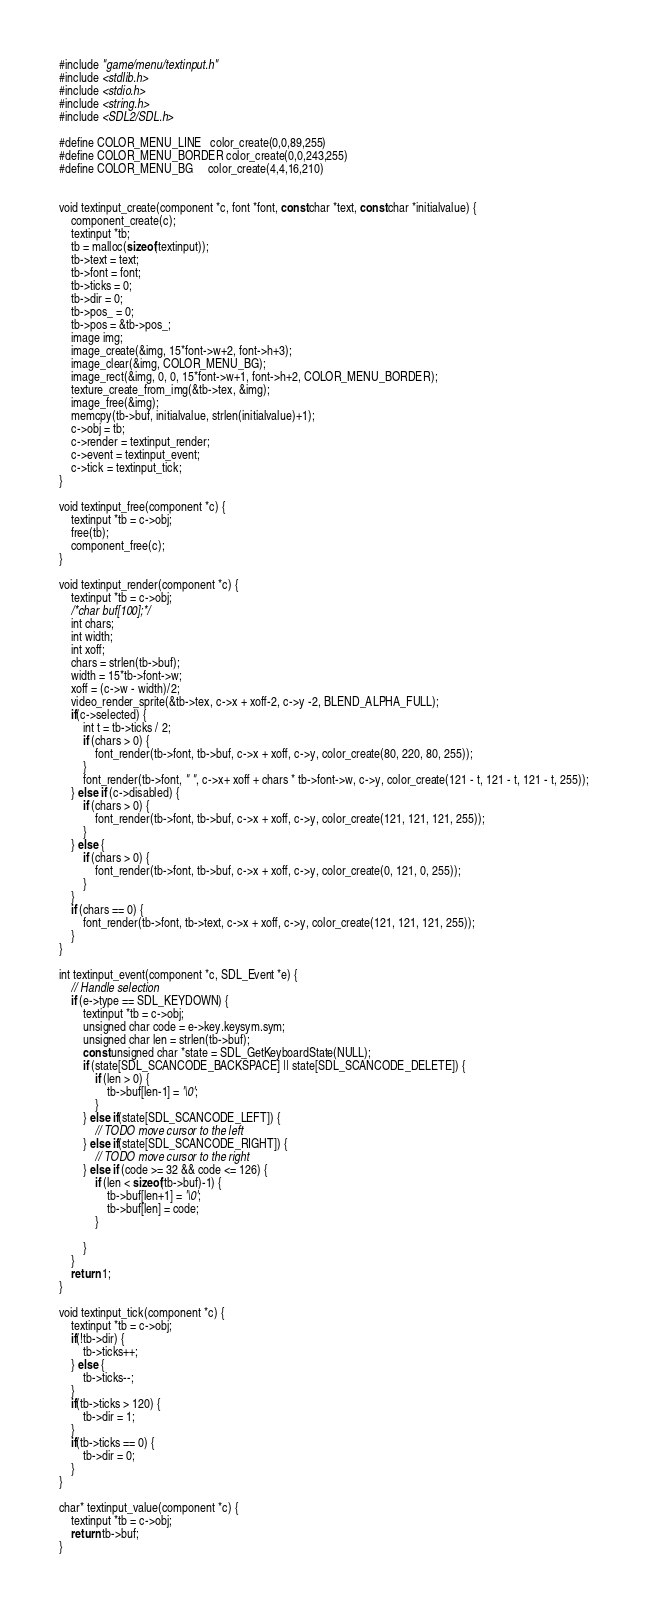Convert code to text. <code><loc_0><loc_0><loc_500><loc_500><_C_>#include "game/menu/textinput.h"
#include <stdlib.h>
#include <stdio.h>
#include <string.h>
#include <SDL2/SDL.h>

#define COLOR_MENU_LINE   color_create(0,0,89,255)
#define COLOR_MENU_BORDER color_create(0,0,243,255)
#define COLOR_MENU_BG     color_create(4,4,16,210)


void textinput_create(component *c, font *font, const char *text, const char *initialvalue) {
    component_create(c);
    textinput *tb;
    tb = malloc(sizeof(textinput));
    tb->text = text;
    tb->font = font;
    tb->ticks = 0;
    tb->dir = 0;
    tb->pos_ = 0;
    tb->pos = &tb->pos_;
    image img;
    image_create(&img, 15*font->w+2, font->h+3);
    image_clear(&img, COLOR_MENU_BG);
    image_rect(&img, 0, 0, 15*font->w+1, font->h+2, COLOR_MENU_BORDER);
    texture_create_from_img(&tb->tex, &img);
    image_free(&img);
    memcpy(tb->buf, initialvalue, strlen(initialvalue)+1);
    c->obj = tb;
    c->render = textinput_render;
    c->event = textinput_event;
    c->tick = textinput_tick;
}

void textinput_free(component *c) {
    textinput *tb = c->obj;
    free(tb);
    component_free(c);
}

void textinput_render(component *c) {
    textinput *tb = c->obj;
    /*char buf[100];*/
    int chars;
    int width;
    int xoff;
    chars = strlen(tb->buf);
    width = 15*tb->font->w;
    xoff = (c->w - width)/2;
    video_render_sprite(&tb->tex, c->x + xoff-2, c->y -2, BLEND_ALPHA_FULL);
    if(c->selected) {
        int t = tb->ticks / 2;
        if (chars > 0) {
            font_render(tb->font, tb->buf, c->x + xoff, c->y, color_create(80, 220, 80, 255));
        }
        font_render(tb->font, "", c->x+ xoff + chars * tb->font->w, c->y, color_create(121 - t, 121 - t, 121 - t, 255));
    } else if (c->disabled) {
        if (chars > 0) {
            font_render(tb->font, tb->buf, c->x + xoff, c->y, color_create(121, 121, 121, 255));
        }
    } else {
        if (chars > 0) {
            font_render(tb->font, tb->buf, c->x + xoff, c->y, color_create(0, 121, 0, 255));
        }
    }
    if (chars == 0) {
        font_render(tb->font, tb->text, c->x + xoff, c->y, color_create(121, 121, 121, 255));
    }
}

int textinput_event(component *c, SDL_Event *e) {
    // Handle selection
    if (e->type == SDL_KEYDOWN) {
        textinput *tb = c->obj;
        unsigned char code = e->key.keysym.sym;
        unsigned char len = strlen(tb->buf);
        const unsigned char *state = SDL_GetKeyboardState(NULL);
        if (state[SDL_SCANCODE_BACKSPACE] || state[SDL_SCANCODE_DELETE]) {
            if (len > 0) {
                tb->buf[len-1] = '\0';
            }
        } else if(state[SDL_SCANCODE_LEFT]) {
            // TODO move cursor to the left
        } else if(state[SDL_SCANCODE_RIGHT]) {
            // TODO move cursor to the right
        } else if (code >= 32 && code <= 126) {
            if (len < sizeof(tb->buf)-1) {
                tb->buf[len+1] = '\0';
                tb->buf[len] = code;
            }

        }
    }
    return 1;
}

void textinput_tick(component *c) {
    textinput *tb = c->obj;
    if(!tb->dir) {
        tb->ticks++;
    } else {
        tb->ticks--;
    }
    if(tb->ticks > 120) {
        tb->dir = 1;
    }
    if(tb->ticks == 0) {
        tb->dir = 0;
    }
}

char* textinput_value(component *c) {
    textinput *tb = c->obj;
    return tb->buf;
}
</code> 